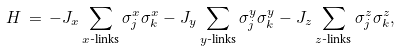Convert formula to latex. <formula><loc_0><loc_0><loc_500><loc_500>H \, = \, - J _ { x } \sum _ { \text {$x$-links} } \sigma _ { j } ^ { x } \sigma _ { k } ^ { x } - J _ { y } \sum _ { \text {$y$-links} } \sigma _ { j } ^ { y } \sigma _ { k } ^ { y } - J _ { z } \sum _ { \text {$z$-links} } \sigma _ { j } ^ { z } \sigma _ { k } ^ { z } ,</formula> 